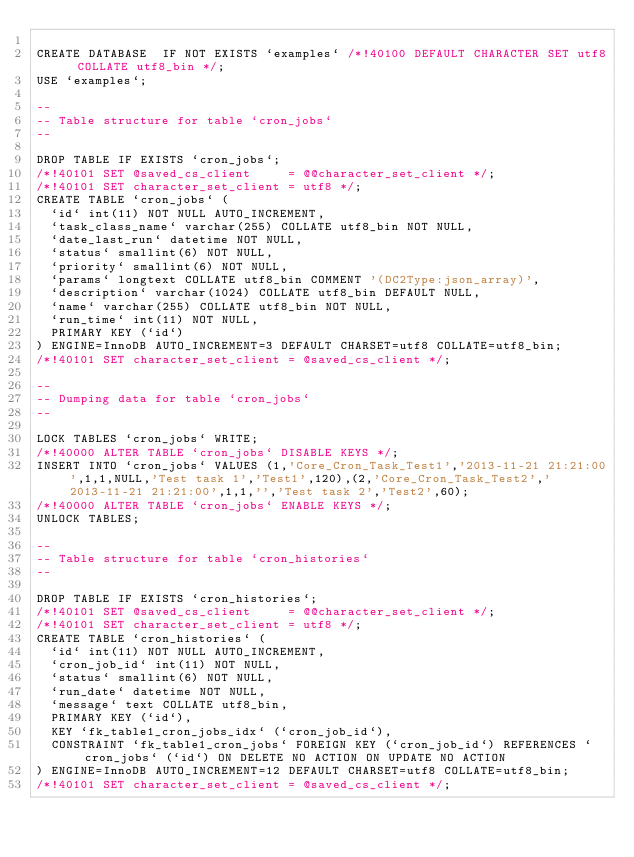Convert code to text. <code><loc_0><loc_0><loc_500><loc_500><_SQL_>
CREATE DATABASE  IF NOT EXISTS `examples` /*!40100 DEFAULT CHARACTER SET utf8 COLLATE utf8_bin */;
USE `examples`;

--
-- Table structure for table `cron_jobs`
--

DROP TABLE IF EXISTS `cron_jobs`;
/*!40101 SET @saved_cs_client     = @@character_set_client */;
/*!40101 SET character_set_client = utf8 */;
CREATE TABLE `cron_jobs` (
  `id` int(11) NOT NULL AUTO_INCREMENT,
  `task_class_name` varchar(255) COLLATE utf8_bin NOT NULL,
  `date_last_run` datetime NOT NULL,
  `status` smallint(6) NOT NULL,
  `priority` smallint(6) NOT NULL,
  `params` longtext COLLATE utf8_bin COMMENT '(DC2Type:json_array)',
  `description` varchar(1024) COLLATE utf8_bin DEFAULT NULL,
  `name` varchar(255) COLLATE utf8_bin NOT NULL,
  `run_time` int(11) NOT NULL,
  PRIMARY KEY (`id`)
) ENGINE=InnoDB AUTO_INCREMENT=3 DEFAULT CHARSET=utf8 COLLATE=utf8_bin;
/*!40101 SET character_set_client = @saved_cs_client */;

--
-- Dumping data for table `cron_jobs`
--

LOCK TABLES `cron_jobs` WRITE;
/*!40000 ALTER TABLE `cron_jobs` DISABLE KEYS */;
INSERT INTO `cron_jobs` VALUES (1,'Core_Cron_Task_Test1','2013-11-21 21:21:00',1,1,NULL,'Test task 1','Test1',120),(2,'Core_Cron_Task_Test2','2013-11-21 21:21:00',1,1,'','Test task 2','Test2',60);
/*!40000 ALTER TABLE `cron_jobs` ENABLE KEYS */;
UNLOCK TABLES;

--
-- Table structure for table `cron_histories`
--

DROP TABLE IF EXISTS `cron_histories`;
/*!40101 SET @saved_cs_client     = @@character_set_client */;
/*!40101 SET character_set_client = utf8 */;
CREATE TABLE `cron_histories` (
  `id` int(11) NOT NULL AUTO_INCREMENT,
  `cron_job_id` int(11) NOT NULL,
  `status` smallint(6) NOT NULL,
  `run_date` datetime NOT NULL,
  `message` text COLLATE utf8_bin,
  PRIMARY KEY (`id`),
  KEY `fk_table1_cron_jobs_idx` (`cron_job_id`),
  CONSTRAINT `fk_table1_cron_jobs` FOREIGN KEY (`cron_job_id`) REFERENCES `cron_jobs` (`id`) ON DELETE NO ACTION ON UPDATE NO ACTION
) ENGINE=InnoDB AUTO_INCREMENT=12 DEFAULT CHARSET=utf8 COLLATE=utf8_bin;
/*!40101 SET character_set_client = @saved_cs_client */;</code> 